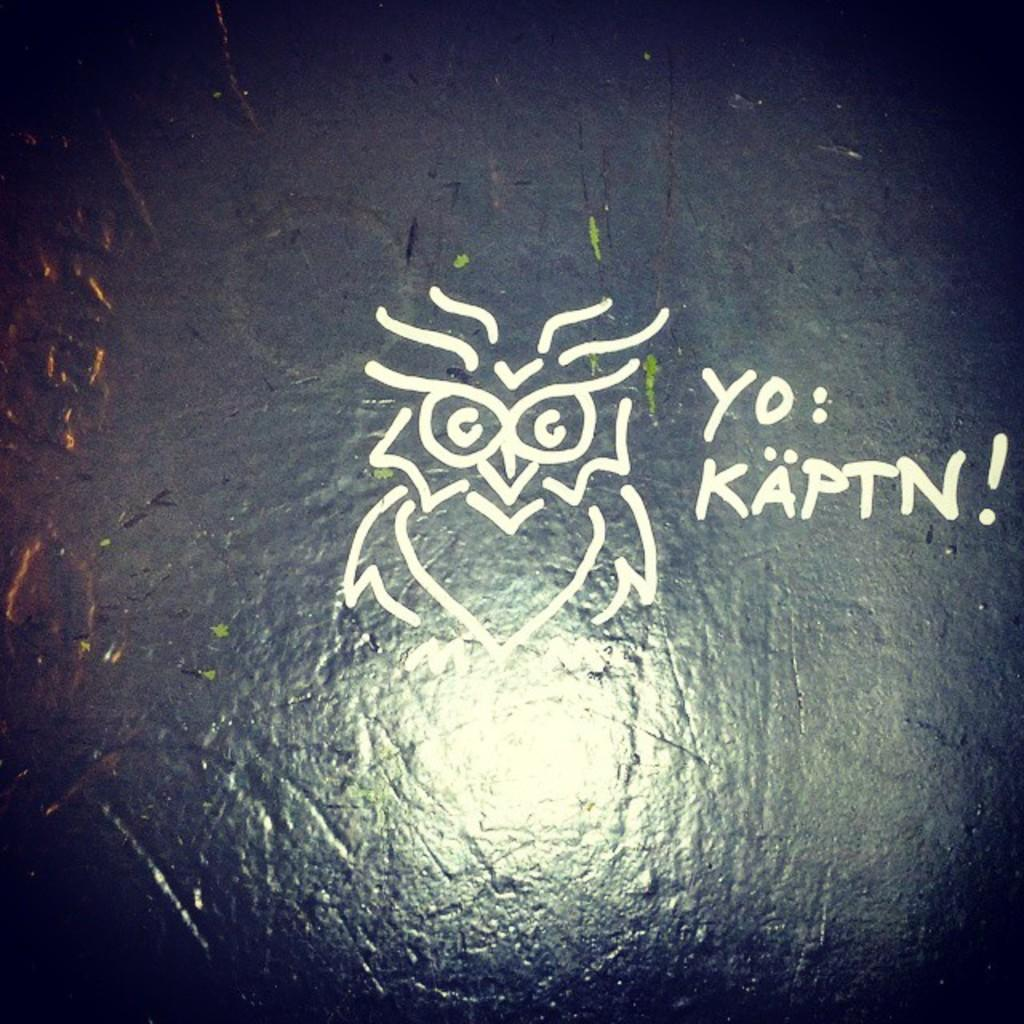What is present on the stone surface in the image? There is text and a design on the stone surface in the image. Can you describe the text on the stone surface? Unfortunately, the specific text cannot be described without more information about the image. What kind of design is visible on the stone surface? The design on the stone surface cannot be described without more information about the image. What direction is the coast facing in the image? There is no coast present in the image, so it is not possible to determine the direction it is facing. 